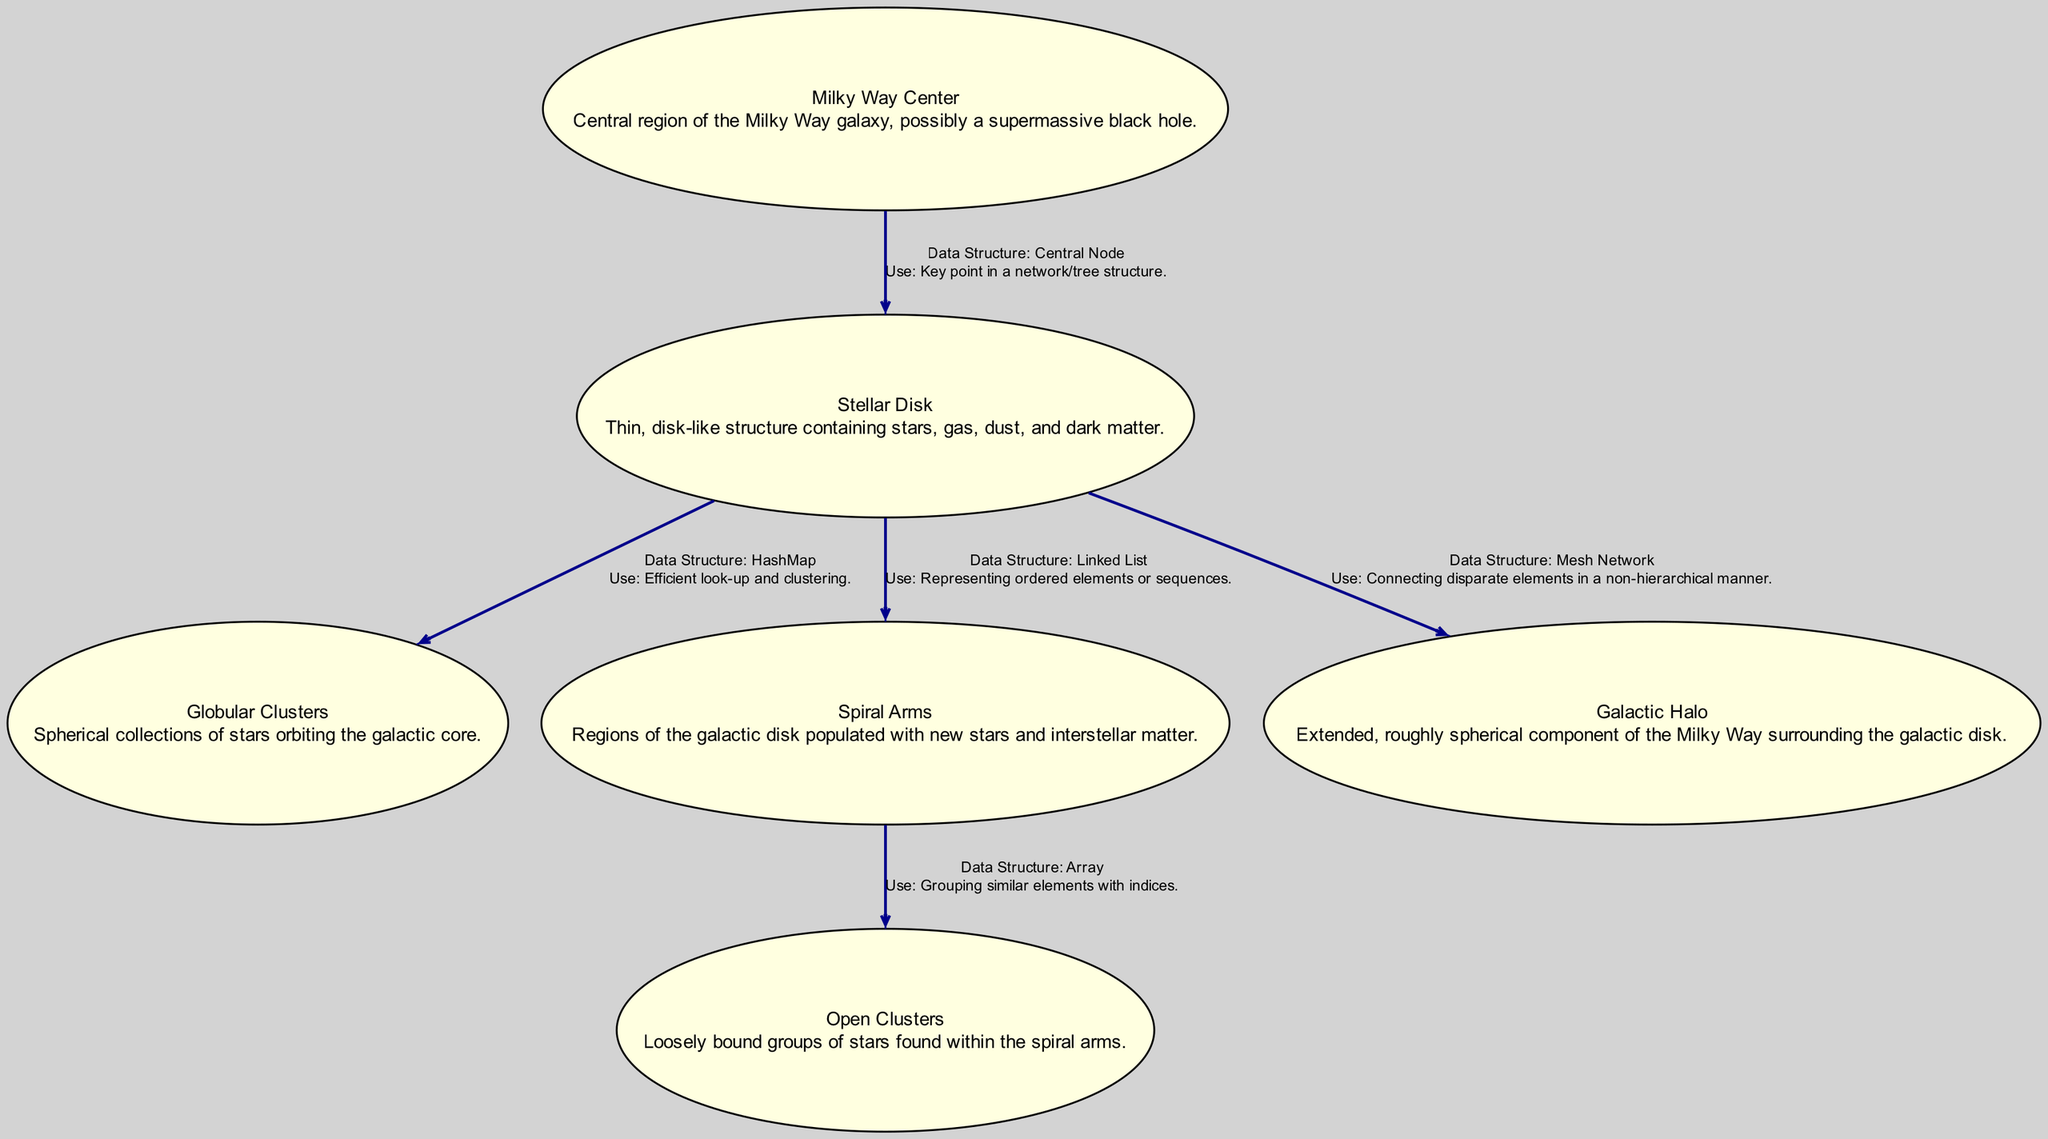What is the central node of the diagram? The diagram has a node labeled "Milky Way Center," which represents the central region of the Milky Way galaxy.
Answer: Milky Way Center How many nodes are there in the diagram? By counting the nodes listed in the data, there are six distinct nodes that represent different stellar objects and components of the Milky Way galaxy.
Answer: 6 What is the relationship between the Stellar Disk and the Galactic Halo? The Stellar Disk is connected to the Galactic Halo with a labeled edge indicating it functions as a mesh network. This suggests a non-hierarchical relationship.
Answer: Mesh Network What data structure is used to represent the relationship between the Spiral Arms and Open Clusters? The relationship between Spiral Arms and Open Clusters is represented using an Array as indicated by the label on the edge connecting the two nodes.
Answer: Array Which node is linked to the Milky Way Center via a central node structure? The Milky Way Center is linked to the Stellar Disk, which is described in the edge as a central node structure within the diagram.
Answer: Stellar Disk What type of stellar collection is represented at the core of the diagram? The node labeled "Globular Clusters" represents a spherical collection of stars orbiting the galactic core.
Answer: Globular Clusters What is the main purpose of the Stellar Disk in the context of the diagram? The Stellar Disk serves as a linked list, indicating it holds ordered elements or sequences integral to the structure of the Milky Way.
Answer: Ordered Elements How do the Open Clusters relate to the structure of the Spiral Arms? Open Clusters are loosely bound groups of stars found within the Spiral Arms, displaying a clear organizational structure within the galaxy.
Answer: Loosely Bound Groups What does the diagram indicate about the structure of the Galactic Halo? The Galactic Halo is depicted as an extended, roughly spherical component surrounding the galactic disk, signifying its expansive and encompassing nature.
Answer: Extended Spherical Component 